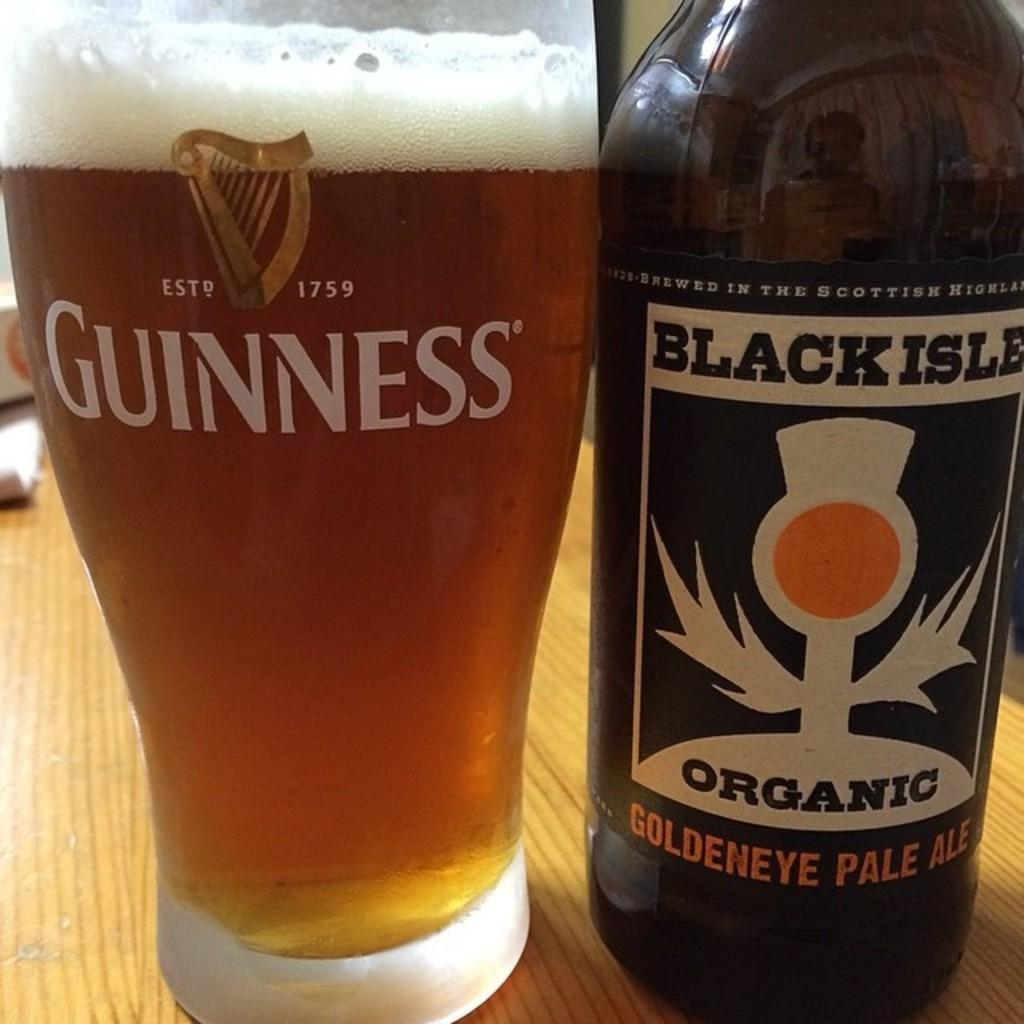<image>
Offer a succinct explanation of the picture presented. A bottle of Black Isle Organic beer is being served in a Guinness beer glass. 